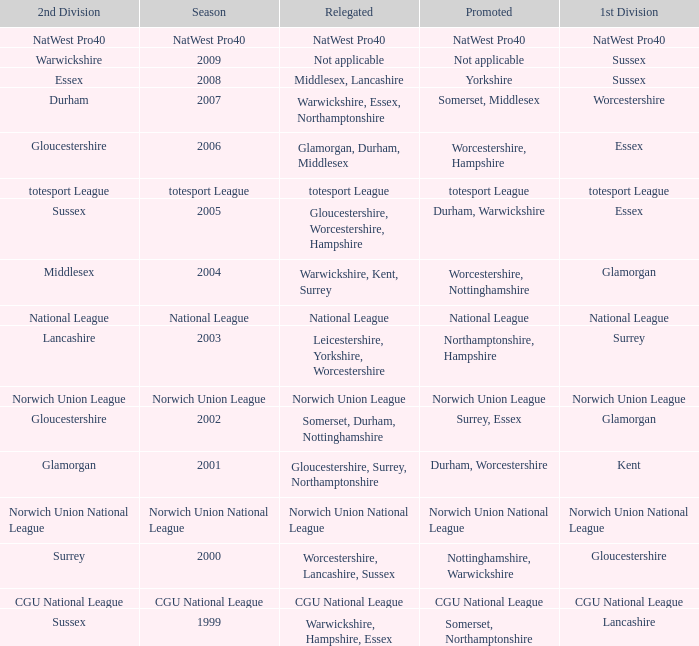What was relegated in the 2006 season? Glamorgan, Durham, Middlesex. 